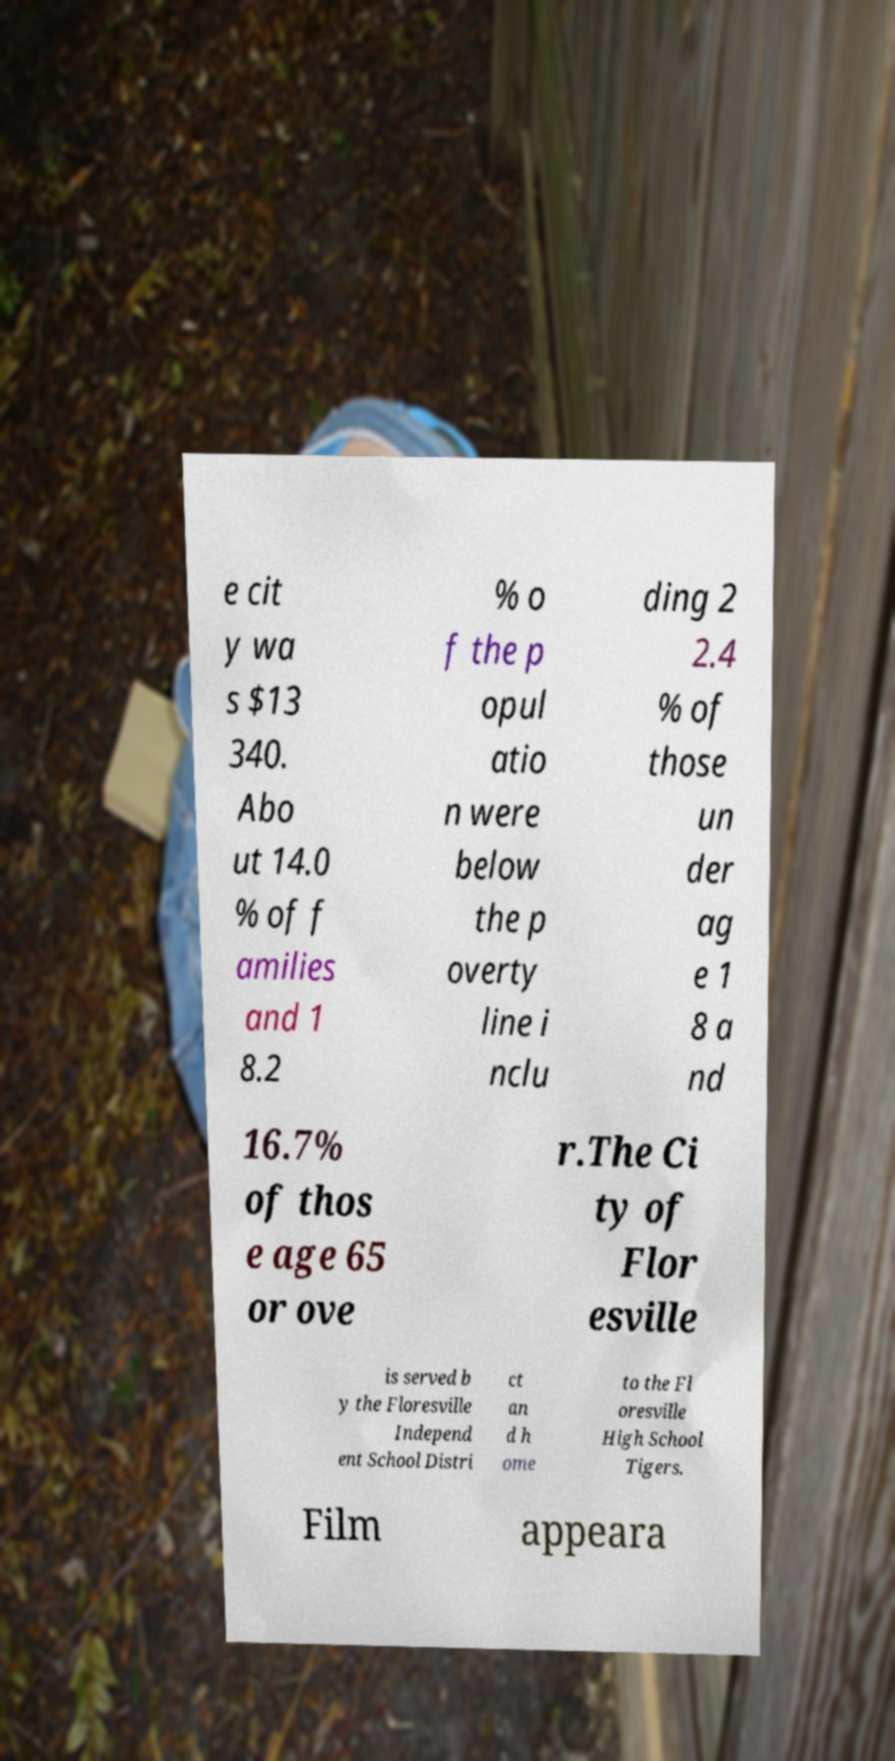Could you assist in decoding the text presented in this image and type it out clearly? e cit y wa s $13 340. Abo ut 14.0 % of f amilies and 1 8.2 % o f the p opul atio n were below the p overty line i nclu ding 2 2.4 % of those un der ag e 1 8 a nd 16.7% of thos e age 65 or ove r.The Ci ty of Flor esville is served b y the Floresville Independ ent School Distri ct an d h ome to the Fl oresville High School Tigers. Film appeara 